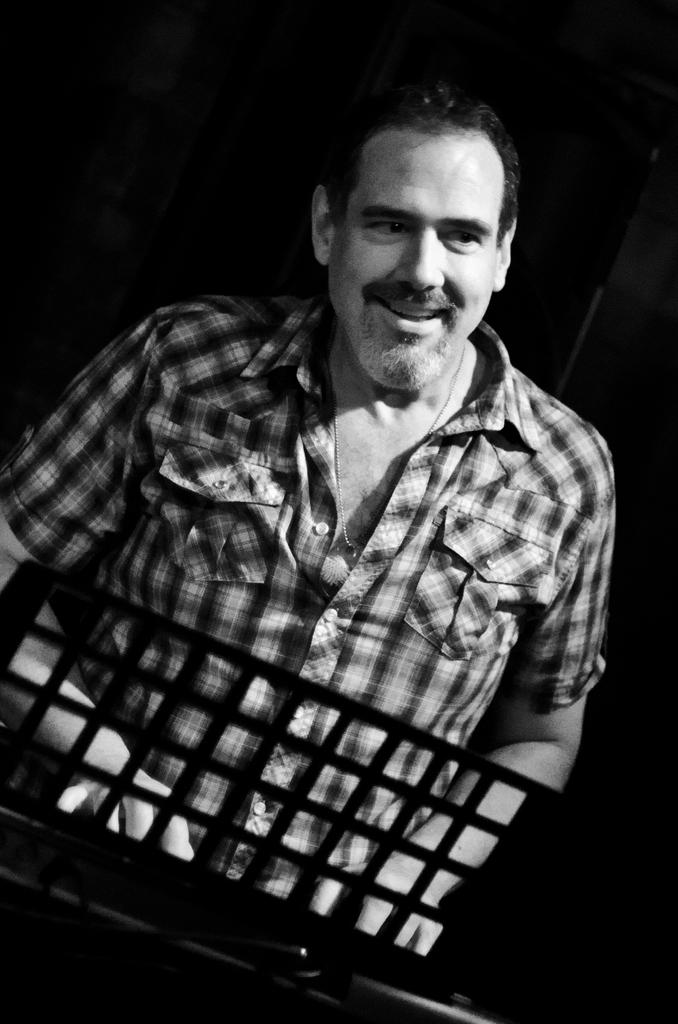What is the color scheme of the image? The image is black and white. What activity is the person in the image engaged in? The person is playing piano in the image. How many members of the family are present in the image? There is no family present in the image; it only features a person playing piano. What type of spot can be seen on the piano in the image? There is no spot visible on the piano in the image, as it is a black and white photograph. 